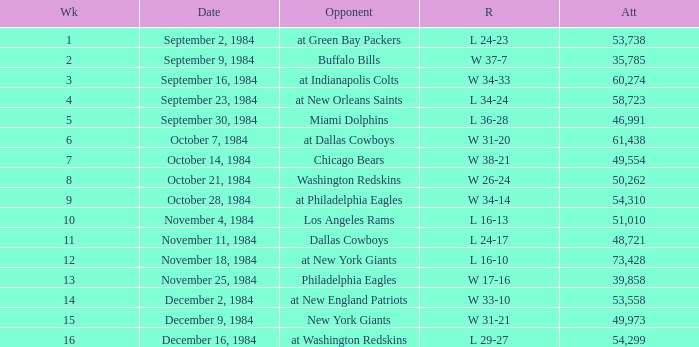What was the result in a week lower than 10 with an opponent of Chicago Bears? W 38-21. 